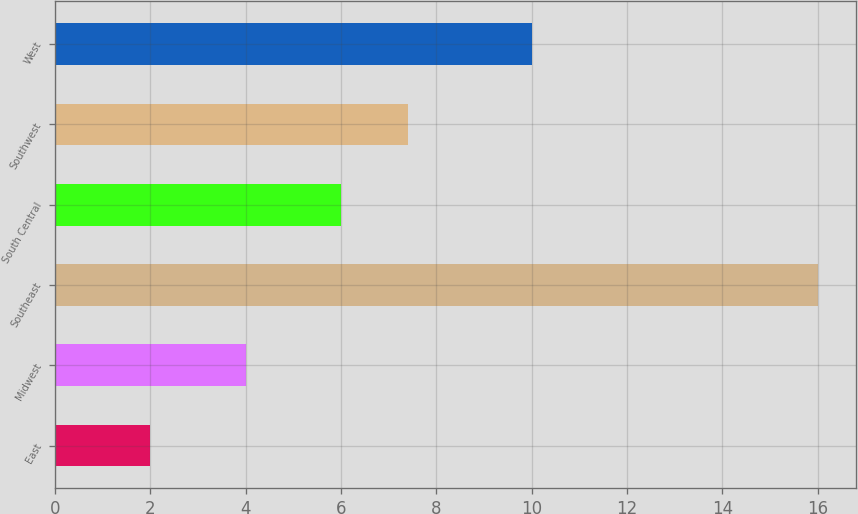<chart> <loc_0><loc_0><loc_500><loc_500><bar_chart><fcel>East<fcel>Midwest<fcel>Southeast<fcel>South Central<fcel>Southwest<fcel>West<nl><fcel>2<fcel>4<fcel>16<fcel>6<fcel>7.4<fcel>10<nl></chart> 